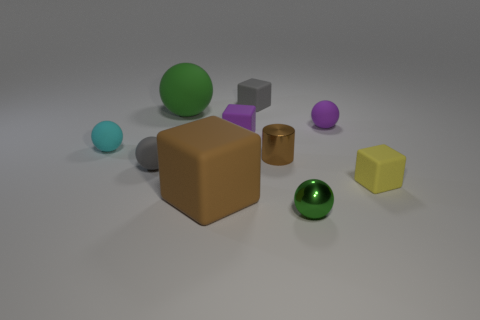Subtract 1 cubes. How many cubes are left? 3 Subtract all cyan spheres. How many spheres are left? 4 Subtract all shiny balls. How many balls are left? 4 Subtract all blue spheres. Subtract all cyan cubes. How many spheres are left? 5 Subtract all cylinders. How many objects are left? 9 Add 5 small balls. How many small balls are left? 9 Add 3 green shiny things. How many green shiny things exist? 4 Subtract 0 gray cylinders. How many objects are left? 10 Subtract all big red cylinders. Subtract all purple matte blocks. How many objects are left? 9 